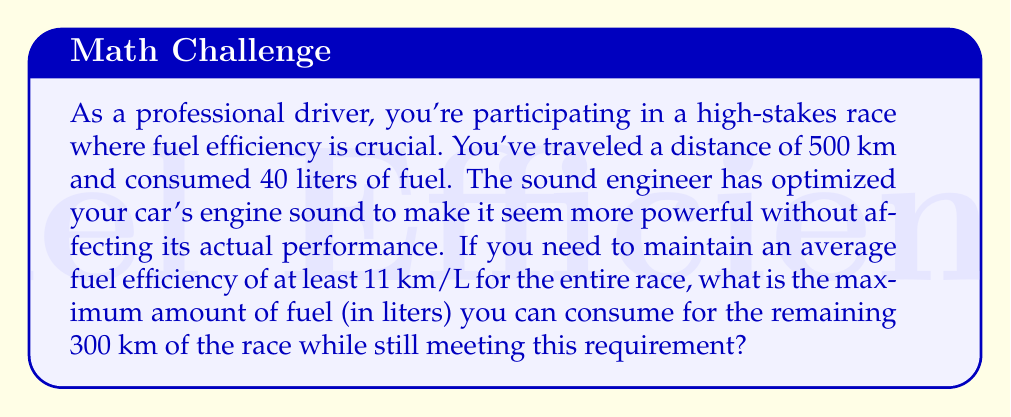Help me with this question. Let's approach this step-by-step:

1) First, we need to calculate the current fuel efficiency:
   $$ \text{Current Efficiency} = \frac{\text{Distance Traveled}}{\text{Fuel Consumed}} = \frac{500 \text{ km}}{40 \text{ L}} = 12.5 \text{ km/L} $$

2) Now, let's define $x$ as the amount of fuel (in liters) that can be consumed for the remaining 300 km.

3) The total distance for the entire race will be 500 km + 300 km = 800 km.

4) The total fuel consumed will be 40 L + $x$ L.

5) We need to maintain an average fuel efficiency of at least 11 km/L for the entire race. This can be expressed as an inequality:

   $$ \frac{\text{Total Distance}}{\text{Total Fuel}} \geq 11 \text{ km/L} $$

   $$ \frac{800}{40 + x} \geq 11 $$

6) Solving this inequality:
   $$ 800 \geq 11(40 + x) $$
   $$ 800 \geq 440 + 11x $$
   $$ 360 \geq 11x $$
   $$ x \leq \frac{360}{11} \approx 32.73 $$

7) Since we're looking for the maximum amount of fuel that can be consumed, we take the upper bound of this inequality.
Answer: The maximum amount of fuel that can be consumed for the remaining 300 km while maintaining an average fuel efficiency of at least 11 km/L for the entire race is approximately 32.73 liters. 